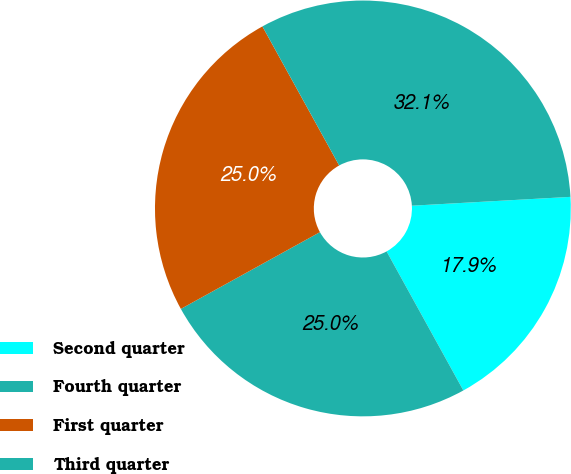Convert chart. <chart><loc_0><loc_0><loc_500><loc_500><pie_chart><fcel>Second quarter<fcel>Fourth quarter<fcel>First quarter<fcel>Third quarter<nl><fcel>17.86%<fcel>25.0%<fcel>25.0%<fcel>32.14%<nl></chart> 